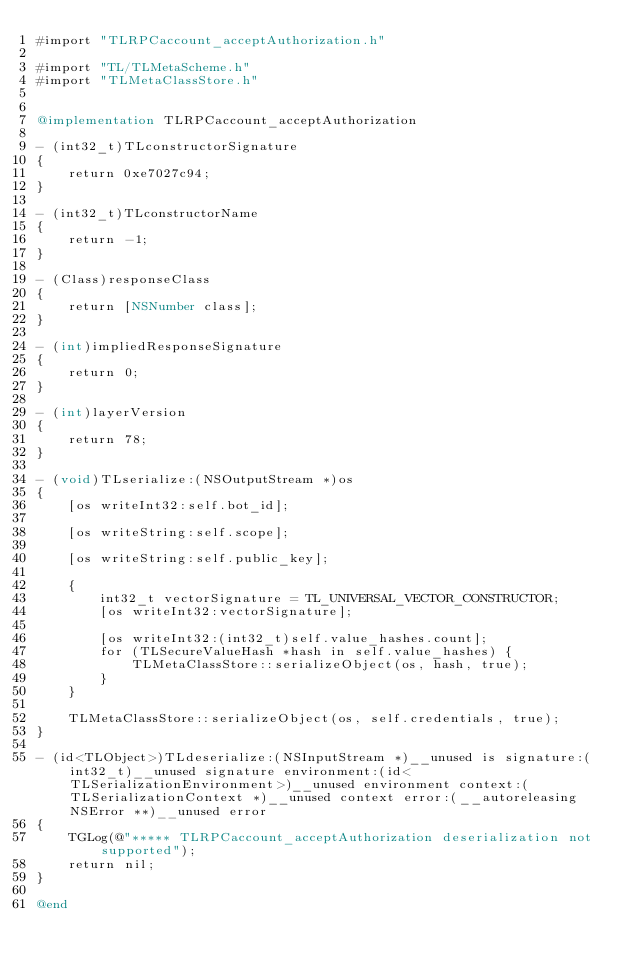<code> <loc_0><loc_0><loc_500><loc_500><_ObjectiveC_>#import "TLRPCaccount_acceptAuthorization.h"

#import "TL/TLMetaScheme.h"
#import "TLMetaClassStore.h"


@implementation TLRPCaccount_acceptAuthorization

- (int32_t)TLconstructorSignature
{
    return 0xe7027c94;
}

- (int32_t)TLconstructorName
{
    return -1;
}

- (Class)responseClass
{
    return [NSNumber class];
}

- (int)impliedResponseSignature
{
    return 0;
}

- (int)layerVersion
{
    return 78;
}

- (void)TLserialize:(NSOutputStream *)os
{
    [os writeInt32:self.bot_id];
    
    [os writeString:self.scope];
    
    [os writeString:self.public_key];
    
    {
        int32_t vectorSignature = TL_UNIVERSAL_VECTOR_CONSTRUCTOR;
        [os writeInt32:vectorSignature];
        
        [os writeInt32:(int32_t)self.value_hashes.count];
        for (TLSecureValueHash *hash in self.value_hashes) {
            TLMetaClassStore::serializeObject(os, hash, true);
        }
    }
    
    TLMetaClassStore::serializeObject(os, self.credentials, true);
}

- (id<TLObject>)TLdeserialize:(NSInputStream *)__unused is signature:(int32_t)__unused signature environment:(id<TLSerializationEnvironment>)__unused environment context:(TLSerializationContext *)__unused context error:(__autoreleasing NSError **)__unused error
{
    TGLog(@"***** TLRPCaccount_acceptAuthorization deserialization not supported");
    return nil;
}

@end


</code> 